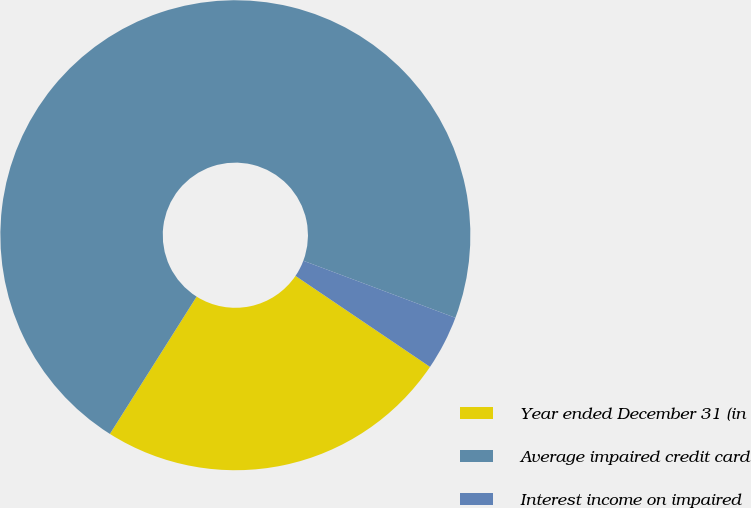<chart> <loc_0><loc_0><loc_500><loc_500><pie_chart><fcel>Year ended December 31 (in<fcel>Average impaired credit card<fcel>Interest income on impaired<nl><fcel>24.5%<fcel>71.75%<fcel>3.75%<nl></chart> 